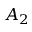<formula> <loc_0><loc_0><loc_500><loc_500>A _ { 2 }</formula> 